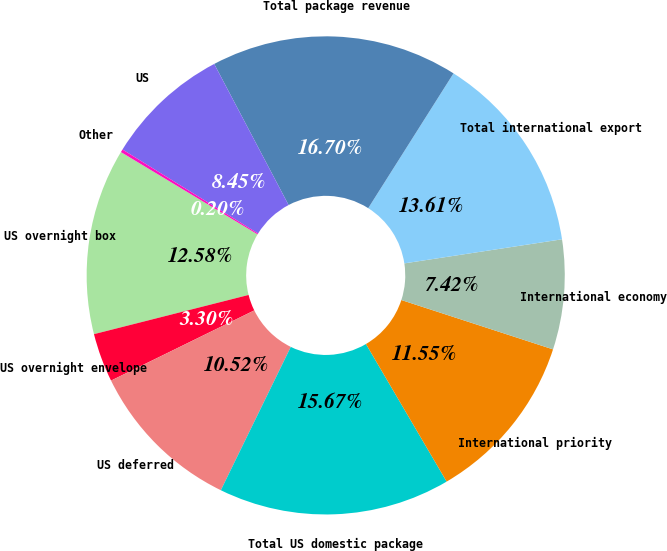Convert chart to OTSL. <chart><loc_0><loc_0><loc_500><loc_500><pie_chart><fcel>US overnight box<fcel>US overnight envelope<fcel>US deferred<fcel>Total US domestic package<fcel>International priority<fcel>International economy<fcel>Total international export<fcel>Total package revenue<fcel>US<fcel>Other<nl><fcel>12.58%<fcel>3.3%<fcel>10.52%<fcel>15.67%<fcel>11.55%<fcel>7.42%<fcel>13.61%<fcel>16.7%<fcel>8.45%<fcel>0.2%<nl></chart> 